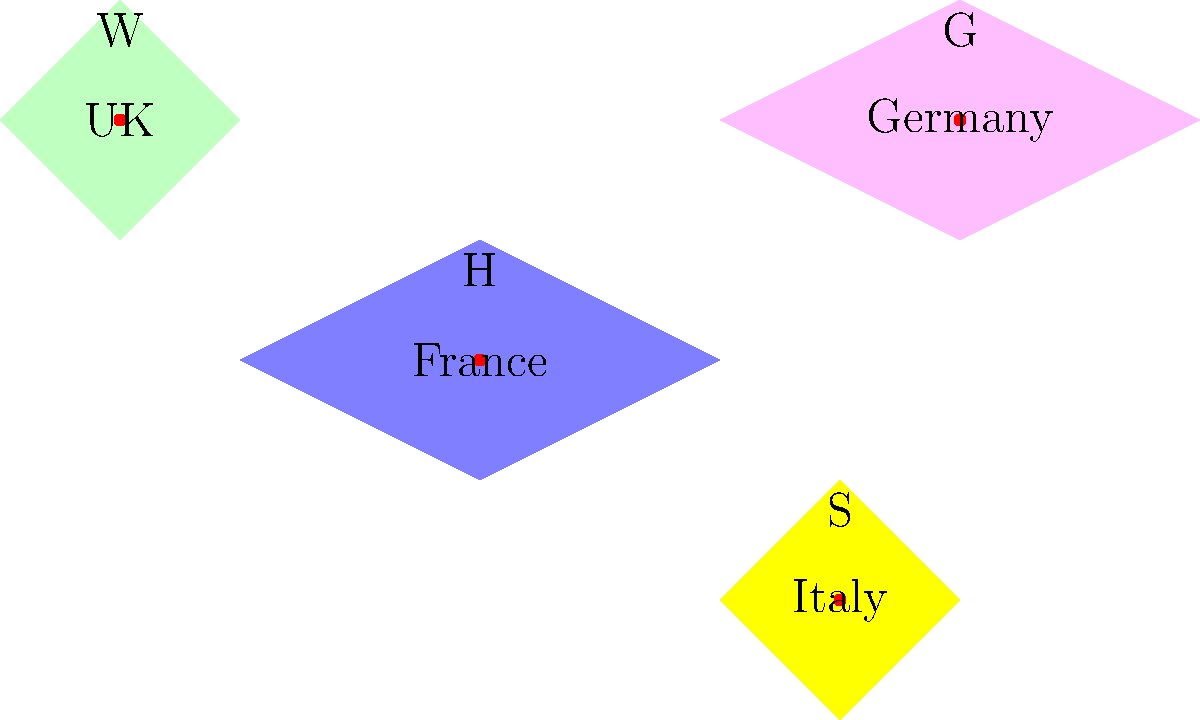Based on the simplified map of Europe shown, which Romantic author is incorrectly placed geographically? To answer this question, we need to analyze the geographical placement of each author represented on the map and compare it with their known origins:

1. W (UK): This likely represents William Wordsworth, who was indeed English and correctly placed in the UK.

2. H (France): This probably stands for Victor Hugo, a French Romantic author, correctly placed in France.

3. G (Germany): This could represent Johann Wolfgang von Goethe, a key figure in German Romanticism, correctly placed in Germany.

4. S (Italy): This is likely meant to represent Percy Bysshe Shelley, an English Romantic poet.

The geographical error lies with the placement of Shelley (S) in Italy. While Shelley did spend time in Italy and even died there, he was born and raised in England and is considered part of the British Romantic movement. His primary association should be with the UK, not Italy.

Therefore, Shelley (S) is incorrectly placed on this map.
Answer: Shelley (S) 